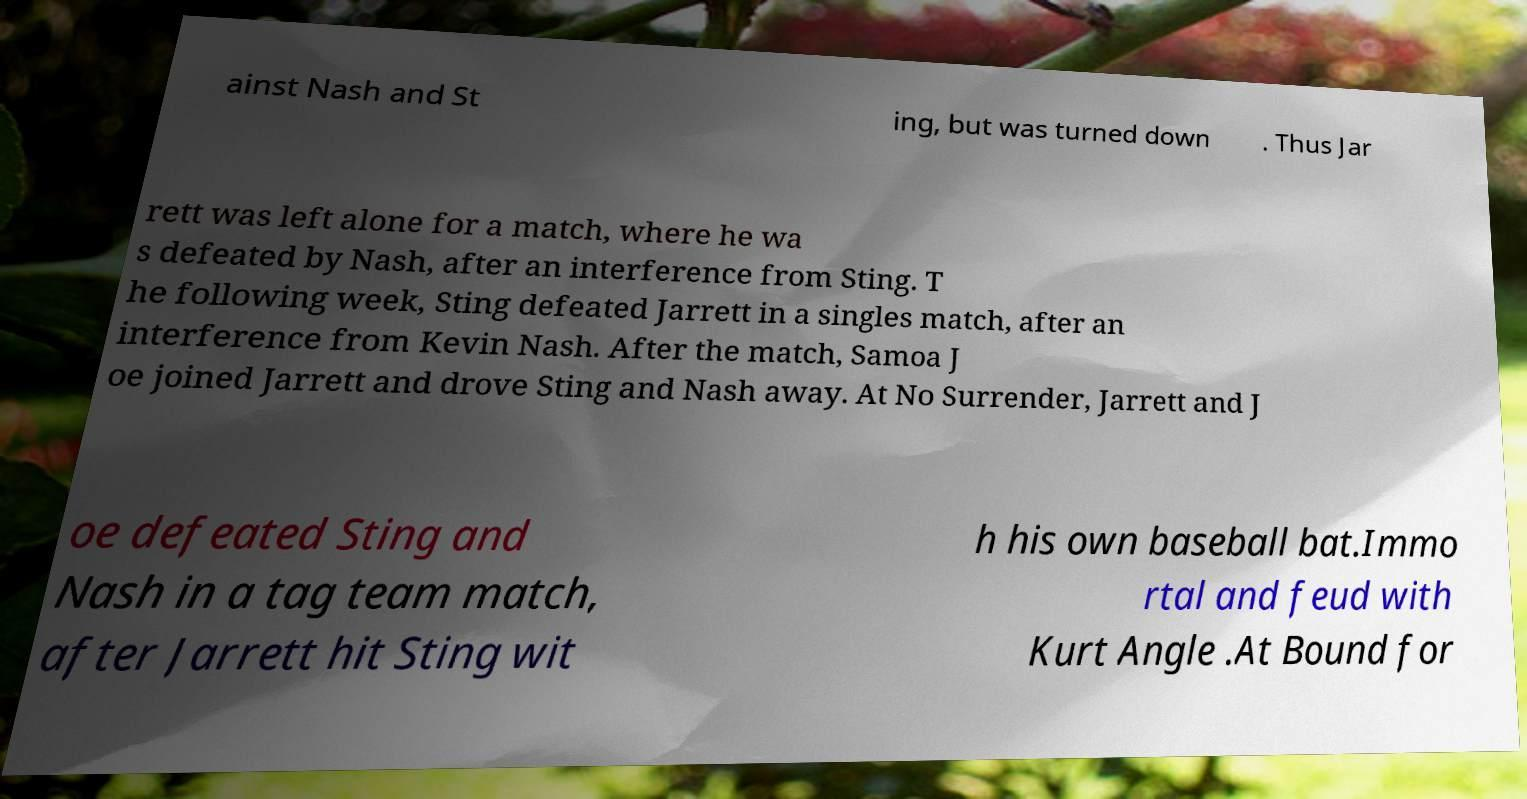Can you read and provide the text displayed in the image?This photo seems to have some interesting text. Can you extract and type it out for me? ainst Nash and St ing, but was turned down . Thus Jar rett was left alone for a match, where he wa s defeated by Nash, after an interference from Sting. T he following week, Sting defeated Jarrett in a singles match, after an interference from Kevin Nash. After the match, Samoa J oe joined Jarrett and drove Sting and Nash away. At No Surrender, Jarrett and J oe defeated Sting and Nash in a tag team match, after Jarrett hit Sting wit h his own baseball bat.Immo rtal and feud with Kurt Angle .At Bound for 